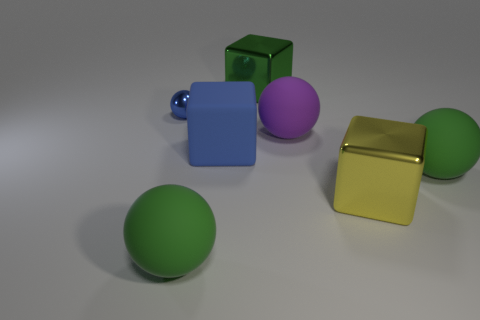Add 1 big blocks. How many objects exist? 8 Subtract all spheres. How many objects are left? 3 Subtract all large purple metallic spheres. Subtract all shiny blocks. How many objects are left? 5 Add 4 big blue cubes. How many big blue cubes are left? 5 Add 1 large green matte spheres. How many large green matte spheres exist? 3 Subtract 0 brown cylinders. How many objects are left? 7 